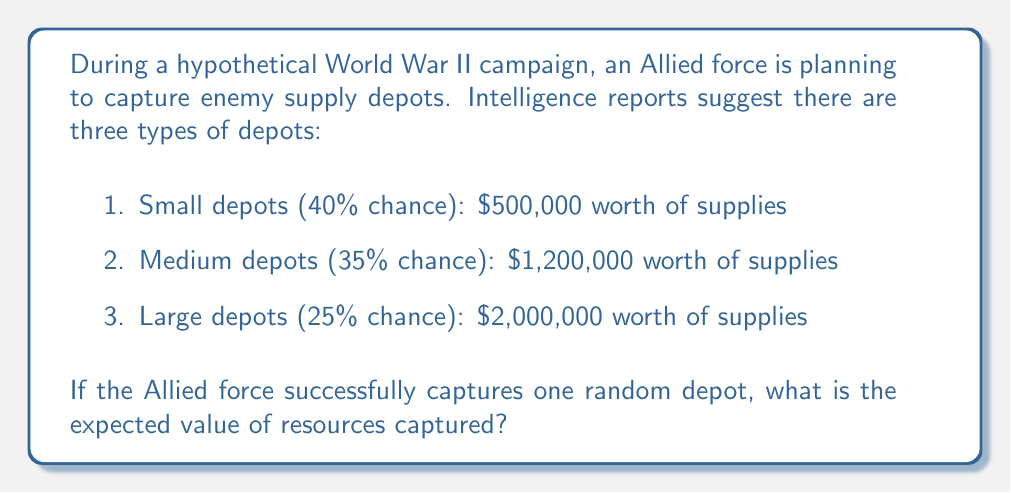Teach me how to tackle this problem. To solve this problem, we need to calculate the expected value using the probability of each outcome and its corresponding value. The formula for expected value is:

$$E(X) = \sum_{i=1}^{n} p_i \cdot x_i$$

Where $p_i$ is the probability of each outcome and $x_i$ is the value of that outcome.

Let's calculate for each depot type:

1. Small depots:
   Probability: $p_1 = 0.40$
   Value: $x_1 = \$500,000$
   $E_1 = 0.40 \cdot \$500,000 = \$200,000$

2. Medium depots:
   Probability: $p_2 = 0.35$
   Value: $x_2 = \$1,200,000$
   $E_2 = 0.35 \cdot \$1,200,000 = \$420,000$

3. Large depots:
   Probability: $p_3 = 0.25$
   Value: $x_3 = \$2,000,000$
   $E_3 = 0.25 \cdot \$2,000,000 = \$500,000$

Now, we sum these values to get the total expected value:

$$E(X) = E_1 + E_2 + E_3 = \$200,000 + \$420,000 + \$500,000 = \$1,120,000$$

Therefore, the expected value of resources captured from a random depot is $\$1,120,000$.
Answer: $\$1,120,000$ 